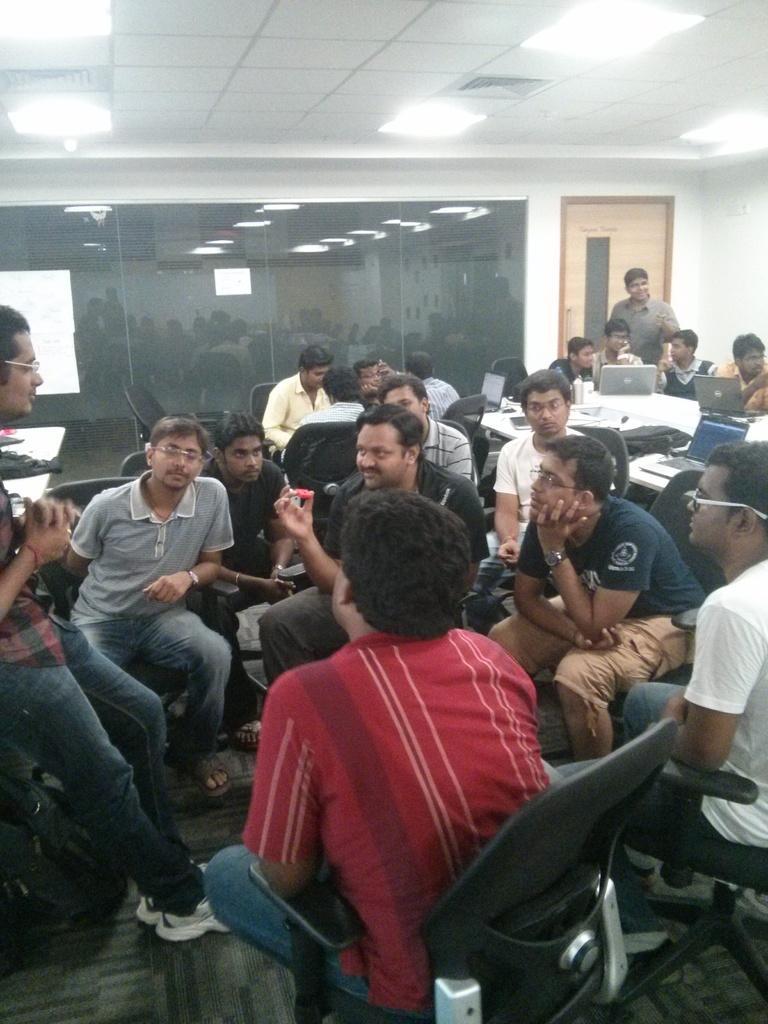Can you describe this image briefly? In this image I can see the ground, number of persons are sitting on chairs and I can see a desk and on the desk I can see few laptops. In the background I can see a person standing, the wall, the door, the ceiling , few lights to the ceiling and the glass surface. 